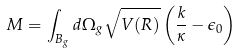<formula> <loc_0><loc_0><loc_500><loc_500>M = \int _ { B _ { g } } d \Omega _ { g } \sqrt { V ( R ) } \left ( \frac { k } { \kappa } - \epsilon _ { 0 } \right )</formula> 